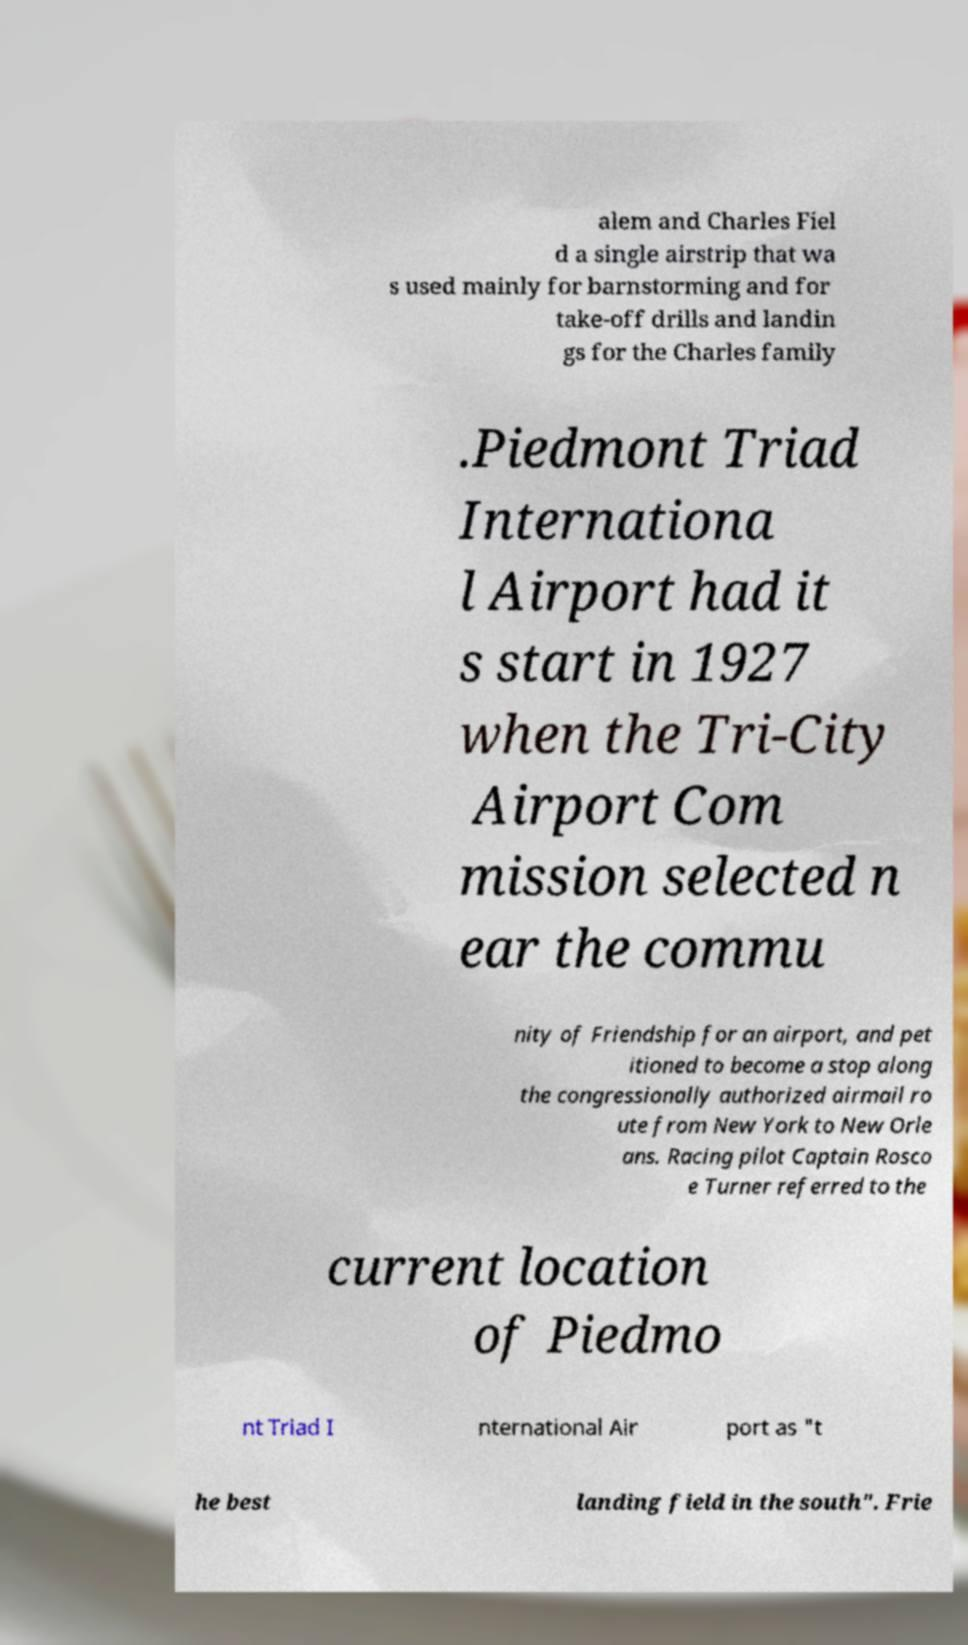Please read and relay the text visible in this image. What does it say? alem and Charles Fiel d a single airstrip that wa s used mainly for barnstorming and for take-off drills and landin gs for the Charles family .Piedmont Triad Internationa l Airport had it s start in 1927 when the Tri-City Airport Com mission selected n ear the commu nity of Friendship for an airport, and pet itioned to become a stop along the congressionally authorized airmail ro ute from New York to New Orle ans. Racing pilot Captain Rosco e Turner referred to the current location of Piedmo nt Triad I nternational Air port as "t he best landing field in the south". Frie 